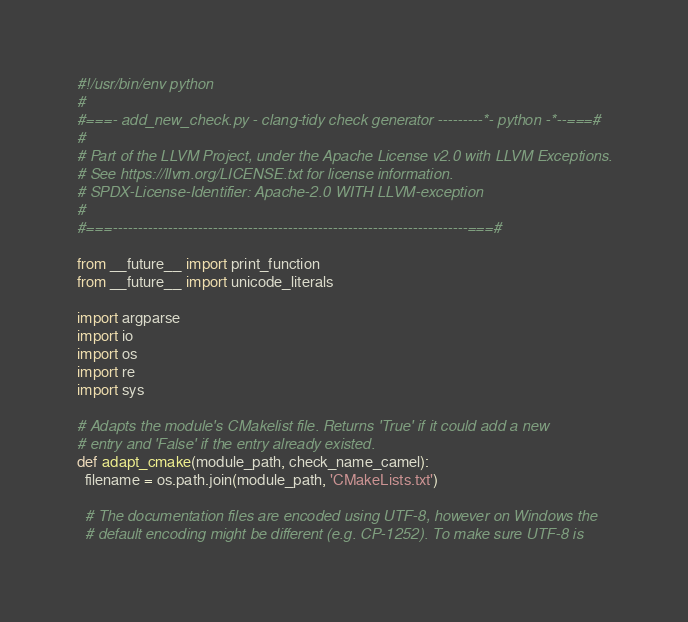<code> <loc_0><loc_0><loc_500><loc_500><_Python_>#!/usr/bin/env python
#
#===- add_new_check.py - clang-tidy check generator ---------*- python -*--===#
#
# Part of the LLVM Project, under the Apache License v2.0 with LLVM Exceptions.
# See https://llvm.org/LICENSE.txt for license information.
# SPDX-License-Identifier: Apache-2.0 WITH LLVM-exception
#
#===-----------------------------------------------------------------------===#

from __future__ import print_function
from __future__ import unicode_literals

import argparse
import io
import os
import re
import sys

# Adapts the module's CMakelist file. Returns 'True' if it could add a new
# entry and 'False' if the entry already existed.
def adapt_cmake(module_path, check_name_camel):
  filename = os.path.join(module_path, 'CMakeLists.txt')

  # The documentation files are encoded using UTF-8, however on Windows the
  # default encoding might be different (e.g. CP-1252). To make sure UTF-8 is</code> 